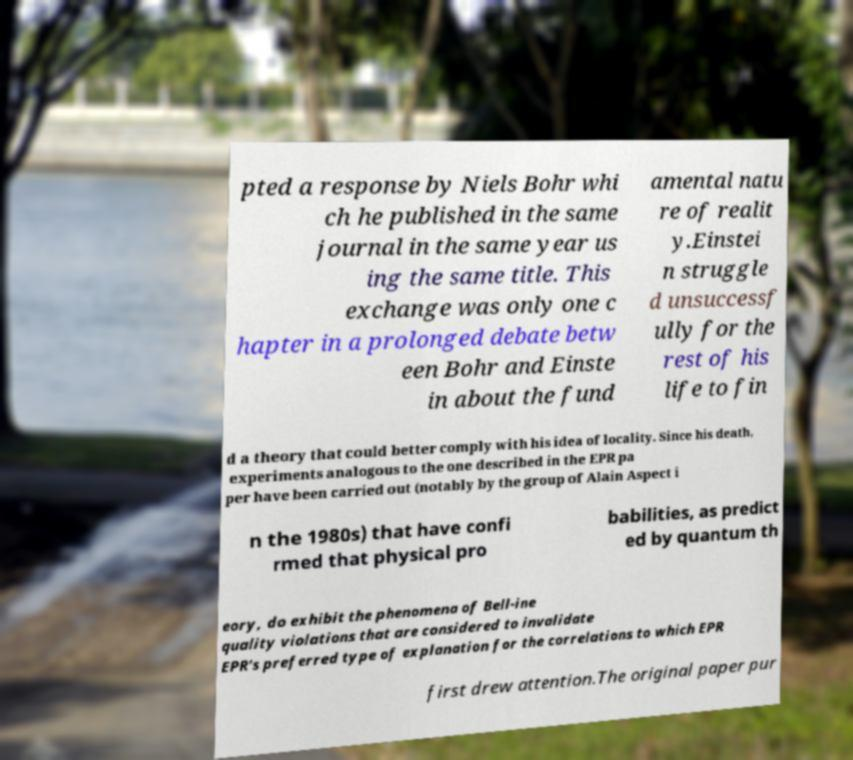Please read and relay the text visible in this image. What does it say? pted a response by Niels Bohr whi ch he published in the same journal in the same year us ing the same title. This exchange was only one c hapter in a prolonged debate betw een Bohr and Einste in about the fund amental natu re of realit y.Einstei n struggle d unsuccessf ully for the rest of his life to fin d a theory that could better comply with his idea of locality. Since his death, experiments analogous to the one described in the EPR pa per have been carried out (notably by the group of Alain Aspect i n the 1980s) that have confi rmed that physical pro babilities, as predict ed by quantum th eory, do exhibit the phenomena of Bell-ine quality violations that are considered to invalidate EPR's preferred type of explanation for the correlations to which EPR first drew attention.The original paper pur 